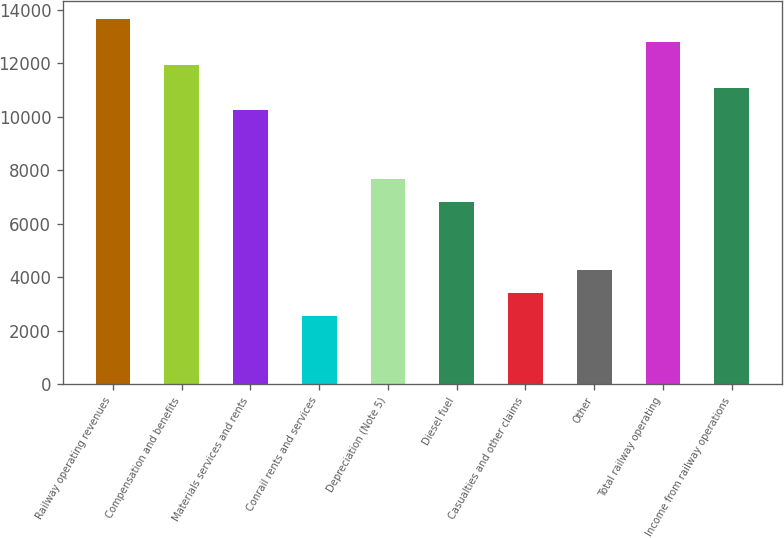<chart> <loc_0><loc_0><loc_500><loc_500><bar_chart><fcel>Railway operating revenues<fcel>Compensation and benefits<fcel>Materials services and rents<fcel>Conrail rents and services<fcel>Depreciation (Note 5)<fcel>Diesel fuel<fcel>Casualties and other claims<fcel>Other<fcel>Total railway operating<fcel>Income from railway operations<nl><fcel>13641.4<fcel>11936.6<fcel>10231.8<fcel>2560.28<fcel>7674.62<fcel>6822.23<fcel>3412.67<fcel>4265.06<fcel>12789<fcel>11084.2<nl></chart> 